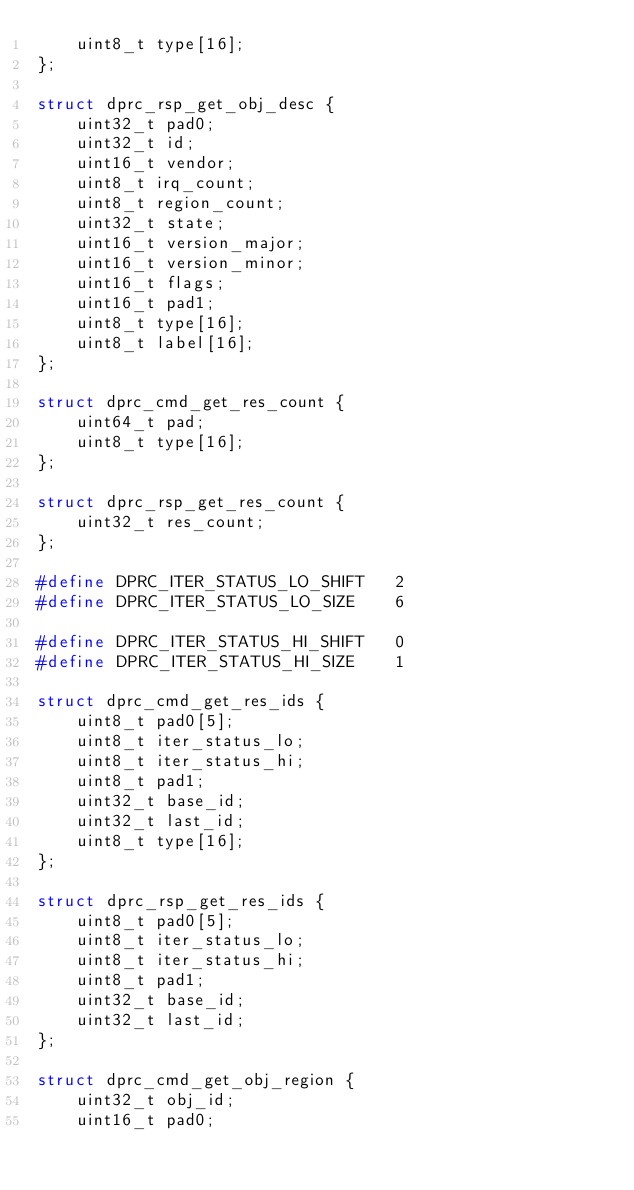<code> <loc_0><loc_0><loc_500><loc_500><_C_>	uint8_t type[16];
};

struct dprc_rsp_get_obj_desc {
	uint32_t pad0;
	uint32_t id;
	uint16_t vendor;
	uint8_t irq_count;
	uint8_t region_count;
	uint32_t state;
	uint16_t version_major;
	uint16_t version_minor;
	uint16_t flags;
	uint16_t pad1;
	uint8_t type[16];
	uint8_t label[16];
};

struct dprc_cmd_get_res_count {
	uint64_t pad;
	uint8_t type[16];
};

struct dprc_rsp_get_res_count {
	uint32_t res_count;
};

#define DPRC_ITER_STATUS_LO_SHIFT	2
#define DPRC_ITER_STATUS_LO_SIZE	6

#define DPRC_ITER_STATUS_HI_SHIFT	0
#define DPRC_ITER_STATUS_HI_SIZE	1

struct dprc_cmd_get_res_ids {
	uint8_t pad0[5];
	uint8_t iter_status_lo;
	uint8_t iter_status_hi;
	uint8_t pad1;
	uint32_t base_id;
	uint32_t last_id;
	uint8_t type[16];
};

struct dprc_rsp_get_res_ids {
	uint8_t pad0[5];
	uint8_t iter_status_lo;
	uint8_t iter_status_hi;
	uint8_t pad1;
	uint32_t base_id;
	uint32_t last_id;
};

struct dprc_cmd_get_obj_region {
	uint32_t obj_id;
	uint16_t pad0;</code> 